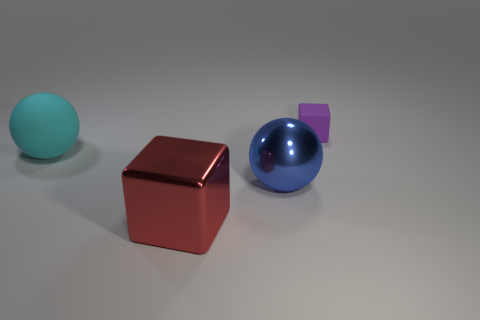Do the shiny thing to the left of the shiny sphere and the cyan matte thing have the same size?
Give a very brief answer. Yes. What number of small matte blocks are there?
Ensure brevity in your answer.  1. What number of blocks are both in front of the blue ball and behind the large cyan matte object?
Ensure brevity in your answer.  0. Are there any tiny blocks that have the same material as the cyan sphere?
Your answer should be very brief. Yes. What material is the object behind the rubber thing to the left of the red object?
Your response must be concise. Rubber. Is the number of cyan rubber spheres that are to the left of the large matte sphere the same as the number of purple things right of the big shiny cube?
Offer a terse response. No. Do the small purple thing and the large cyan object have the same shape?
Make the answer very short. No. There is a large thing that is to the left of the blue metal object and right of the large matte ball; what material is it?
Your answer should be very brief. Metal. What number of other large things have the same shape as the large blue thing?
Give a very brief answer. 1. What size is the rubber object that is on the right side of the block that is left of the tiny block that is right of the large cyan rubber ball?
Provide a short and direct response. Small. 